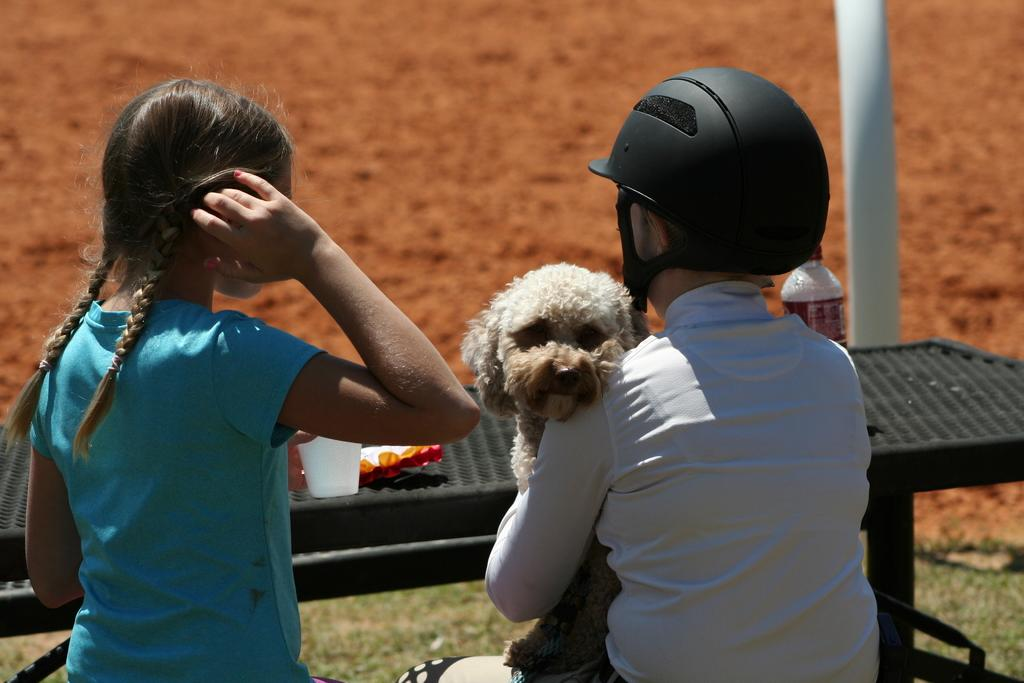How many people are in the image? There are two persons in the image. What is one person wearing on their head? One person is wearing a black helmet. What is the person with the black helmet holding? The person with the black helmet is holding a dog. What objects can be seen on the table in the image? There is a glass and a bottle on the table. What type of terrain is visible at the bottom of the image? There is sand and grass at the bottom of the image. What color is the brain visible in the image? There is no brain visible in the image. What type of line is present in the image? There is no line present in the image. 